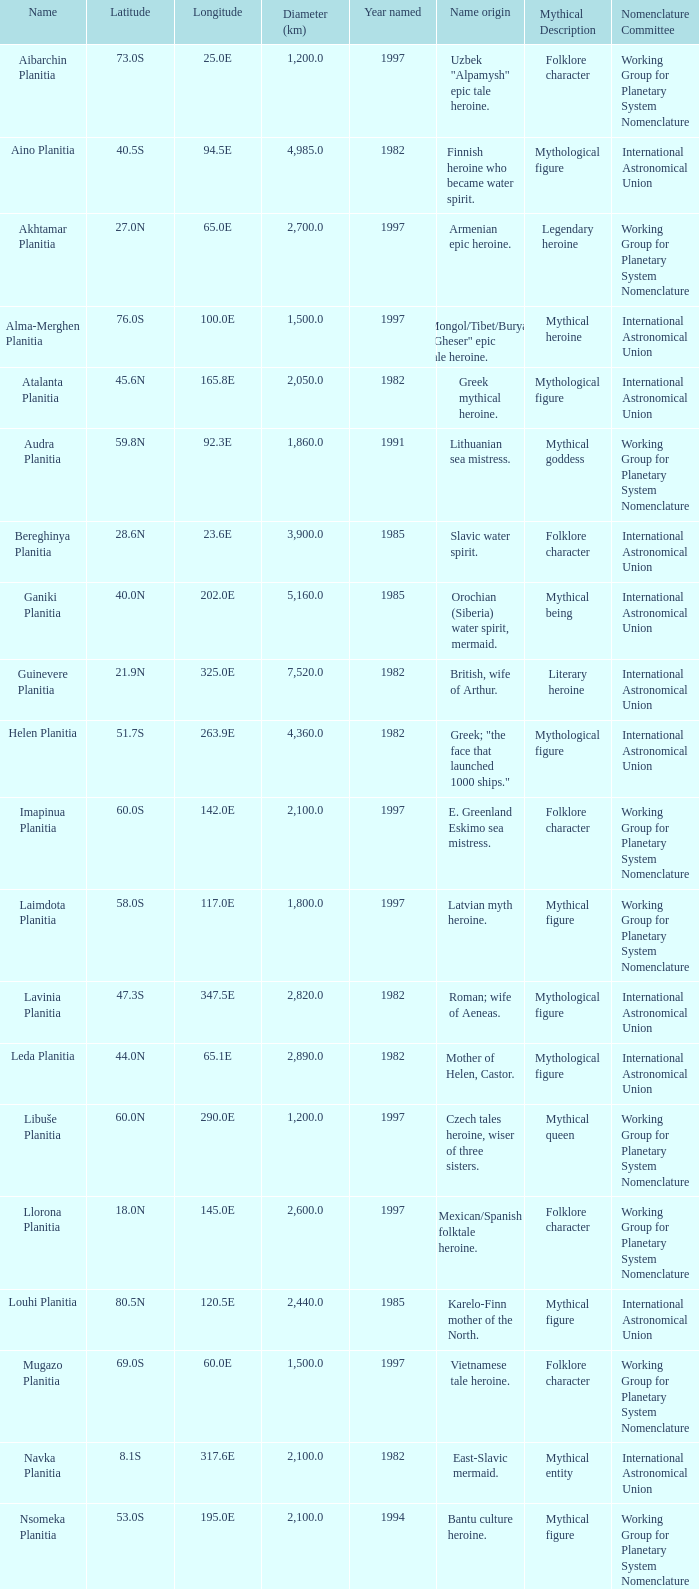What is the latitude of the feature of longitude 80.0e 23.0S. Would you be able to parse every entry in this table? {'header': ['Name', 'Latitude', 'Longitude', 'Diameter (km)', 'Year named', 'Name origin', 'Mythical Description', 'Nomenclature Committee'], 'rows': [['Aibarchin Planitia', '73.0S', '25.0E', '1,200.0', '1997', 'Uzbek "Alpamysh" epic tale heroine.', 'Folklore character', 'Working Group for Planetary System Nomenclature '], ['Aino Planitia', '40.5S', '94.5E', '4,985.0', '1982', 'Finnish heroine who became water spirit.', 'Mythological figure', 'International Astronomical Union '], ['Akhtamar Planitia', '27.0N', '65.0E', '2,700.0', '1997', 'Armenian epic heroine.', 'Legendary heroine', 'Working Group for Planetary System Nomenclature '], ['Alma-Merghen Planitia', '76.0S', '100.0E', '1,500.0', '1997', 'Mongol/Tibet/Buryat "Gheser" epic tale heroine.', 'Mythical heroine', 'International Astronomical Union '], ['Atalanta Planitia', '45.6N', '165.8E', '2,050.0', '1982', 'Greek mythical heroine.', 'Mythological figure', 'International Astronomical Union '], ['Audra Planitia', '59.8N', '92.3E', '1,860.0', '1991', 'Lithuanian sea mistress.', 'Mythical goddess', 'Working Group for Planetary System Nomenclature '], ['Bereghinya Planitia', '28.6N', '23.6E', '3,900.0', '1985', 'Slavic water spirit.', 'Folklore character', 'International Astronomical Union '], ['Ganiki Planitia', '40.0N', '202.0E', '5,160.0', '1985', 'Orochian (Siberia) water spirit, mermaid.', 'Mythical being', 'International Astronomical Union '], ['Guinevere Planitia', '21.9N', '325.0E', '7,520.0', '1982', 'British, wife of Arthur.', 'Literary heroine', 'International Astronomical Union '], ['Helen Planitia', '51.7S', '263.9E', '4,360.0', '1982', 'Greek; "the face that launched 1000 ships."', 'Mythological figure', 'International Astronomical Union '], ['Imapinua Planitia', '60.0S', '142.0E', '2,100.0', '1997', 'E. Greenland Eskimo sea mistress.', 'Folklore character', 'Working Group for Planetary System Nomenclature '], ['Laimdota Planitia', '58.0S', '117.0E', '1,800.0', '1997', 'Latvian myth heroine.', 'Mythical figure', 'Working Group for Planetary System Nomenclature '], ['Lavinia Planitia', '47.3S', '347.5E', '2,820.0', '1982', 'Roman; wife of Aeneas.', 'Mythological figure', 'International Astronomical Union '], ['Leda Planitia', '44.0N', '65.1E', '2,890.0', '1982', 'Mother of Helen, Castor.', 'Mythological figure', 'International Astronomical Union '], ['Libuše Planitia', '60.0N', '290.0E', '1,200.0', '1997', 'Czech tales heroine, wiser of three sisters.', 'Mythical queen', 'Working Group for Planetary System Nomenclature '], ['Llorona Planitia', '18.0N', '145.0E', '2,600.0', '1997', 'Mexican/Spanish folktale heroine.', 'Folklore character', 'Working Group for Planetary System Nomenclature '], ['Louhi Planitia', '80.5N', '120.5E', '2,440.0', '1985', 'Karelo-Finn mother of the North.', 'Mythical figure', 'International Astronomical Union '], ['Mugazo Planitia', '69.0S', '60.0E', '1,500.0', '1997', 'Vietnamese tale heroine.', 'Folklore character', 'Working Group for Planetary System Nomenclature '], ['Navka Planitia', '8.1S', '317.6E', '2,100.0', '1982', 'East-Slavic mermaid.', 'Mythical entity', 'International Astronomical Union '], ['Nsomeka Planitia', '53.0S', '195.0E', '2,100.0', '1994', 'Bantu culture heroine.', 'Mythical figure', 'Working Group for Planetary System Nomenclature '], ['Rusalka Planitia', '9.8N', '170.1E', '3,655.0', '1982', 'Russian mermaid.', 'Mythological character', 'International Astronomical Union '], ['Sedna Planitia', '42.7N', '340.7E', '3,570.0', '1982', 'Eskimo; her fingers became seals and whales.', 'Mythical figure', 'International Astronomical Union '], ['Tahmina Planitia', '23.0S', '80.0E', '3,000.0', '1997', 'Iranian epic heroine, wife of knight Rustam.', 'Mythical character', 'Working Group for Planetary System Nomenclature '], ['Tilli-Hanum Planitia', '54.0N', '120.0E', '2,300.0', '1997', 'Azeri "Ker-ogly" epic tale heroine.', 'Folklore figure', 'Working Group for Planetary System Nomenclature '], ['Tinatin Planitia', '15.0S', '15.0E', '0.0', '1994', 'Georgian epic heroine.', 'Mythical character', 'Working Group for Planetary System Nomenclature '], ['Undine Planitia', '13.0N', '303.0E', '2,800.0', '1997', 'Lithuanian water nymph, mermaid.', 'Mythical creature', 'Working Group for Planetary System Nomenclature '], ['Vellamo Planitia', '45.4N', '149.1E', '2,155.0', '1985', 'Karelo-Finn mermaid.', 'Mythological figure', 'International Astronomical Union']]} 